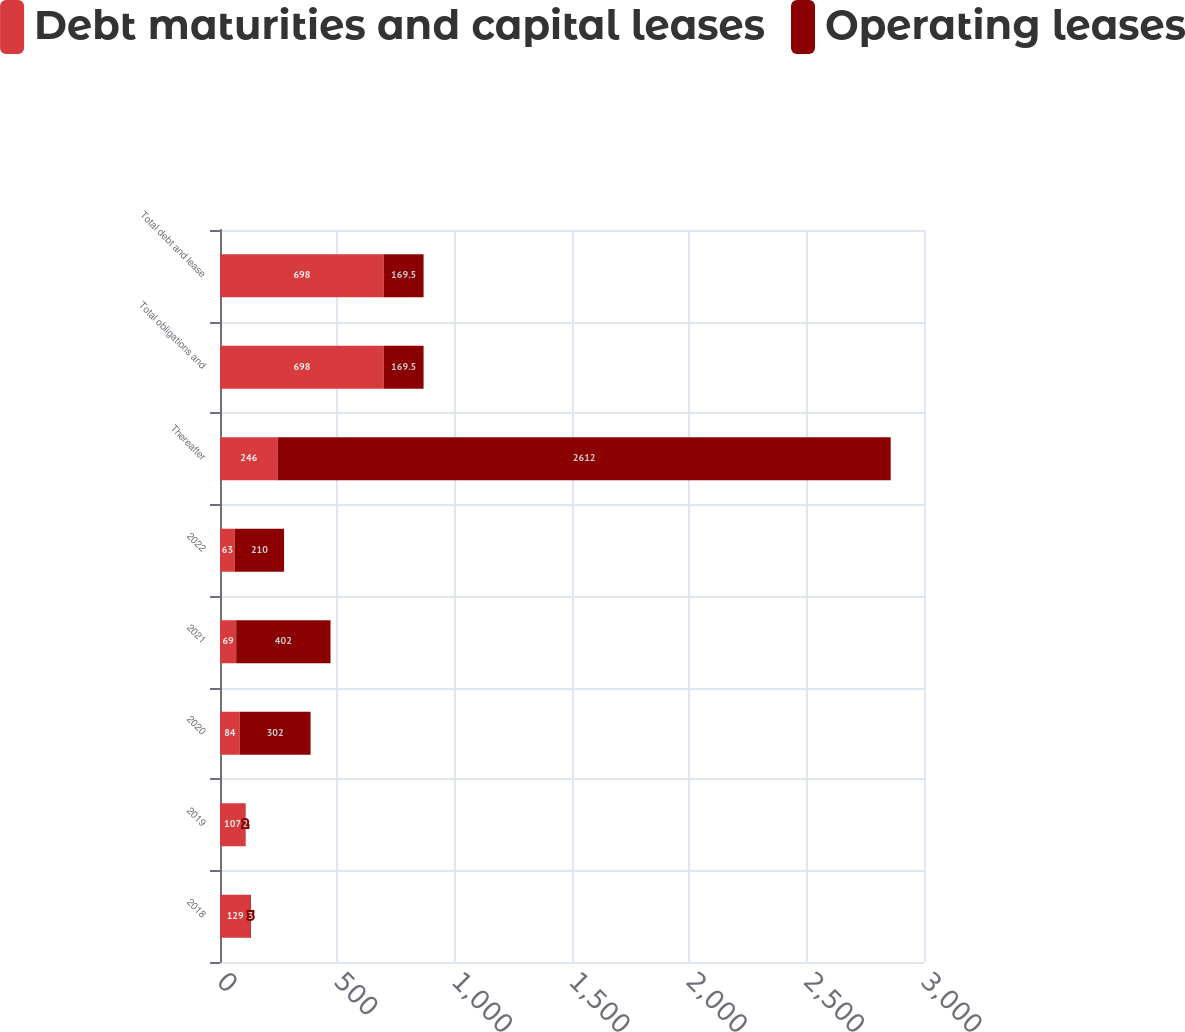Convert chart. <chart><loc_0><loc_0><loc_500><loc_500><stacked_bar_chart><ecel><fcel>2018<fcel>2019<fcel>2020<fcel>2021<fcel>2022<fcel>Thereafter<fcel>Total obligations and<fcel>Total debt and lease<nl><fcel>Debt maturities and capital leases<fcel>129<fcel>107<fcel>84<fcel>69<fcel>63<fcel>246<fcel>698<fcel>698<nl><fcel>Operating leases<fcel>3<fcel>2<fcel>302<fcel>402<fcel>210<fcel>2612<fcel>169.5<fcel>169.5<nl></chart> 